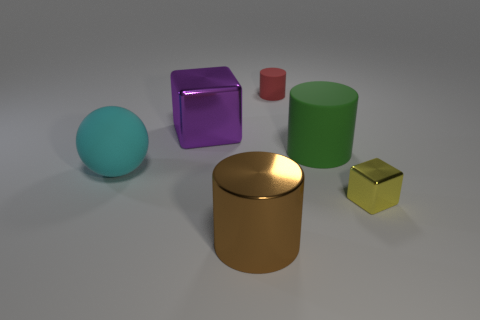Subtract all large cylinders. How many cylinders are left? 1 Add 3 tiny red things. How many objects exist? 9 Subtract all yellow blocks. How many blocks are left? 1 Subtract 1 cylinders. How many cylinders are left? 2 Subtract all balls. How many objects are left? 5 Subtract all cyan blocks. Subtract all cyan balls. How many blocks are left? 2 Subtract all big purple blocks. Subtract all big things. How many objects are left? 1 Add 2 red rubber cylinders. How many red rubber cylinders are left? 3 Add 5 tiny brown rubber things. How many tiny brown rubber things exist? 5 Subtract 0 blue blocks. How many objects are left? 6 